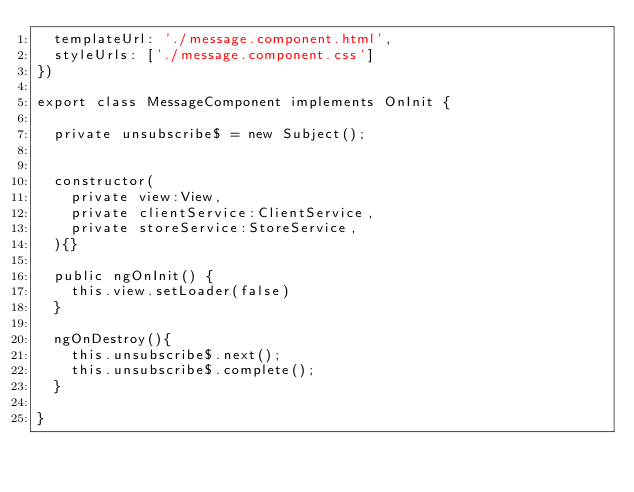Convert code to text. <code><loc_0><loc_0><loc_500><loc_500><_TypeScript_>  templateUrl: './message.component.html',
  styleUrls: ['./message.component.css']
})

export class MessageComponent implements OnInit {

  private unsubscribe$ = new Subject();

  
  constructor(
    private view:View,
    private clientService:ClientService,
    private storeService:StoreService,
  ){}

  public ngOnInit() {
    this.view.setLoader(false)
  }

  ngOnDestroy(){
    this.unsubscribe$.next();
    this.unsubscribe$.complete();
  }

}
</code> 